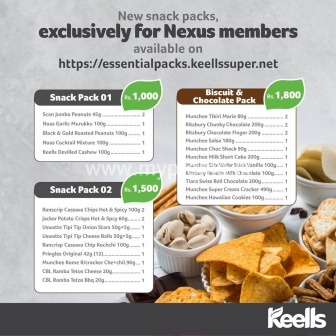If this image were part of a story, what might the story be? Once upon a time in the bustling city of Flavourville, there was an old, charming supermarket named Keells that was known for its rare and exquisite snack packs, available only to its cherished Nexus members. One day, an ambitious young chef named Alex stumbled upon a cryptic message on the store's website promoting these exclusive packs. Intrigued, Alex decided to embark on a flavorful journey to uncover the secrets behind these divine snacks.

Alex became a Nexus member and began exploring each snack pack, discovering unique ingredients and recipes that had been long forgotten by time. Each treat unlocked a new culinary inspiration, helping Alex create dishes that wowed critics and food lovers alike. The supermarket became a hub of culinary excellence, with people traveling from far and wide to taste the creations inspired by the Keells snack packs. And thus, Keells not only revived the lost art of gourmet snacking but also sparked a culinary renaissance in Flavourville, all thanks to the magic and mystery of their one-of-a-kind snack packs. That sounds like a great story! How about a short scenario set in modern times? In today's fast-paced world, Nexus loyalty program members eagerly await the announcement of new snack packs from Keells. Maria, a busy executive, looks forward to these releases as they provide not just a quick snack but a moment of joy in her hectic day. With a variety of options in one convenient pack, Maria can choose from healthy nuts, crunchy chips, and indulgent chocolates without needing to leave her office. These snack packs have become her small daily luxury, helping her power through meetings and deadlines with just a bit more cheer. Describe a scenario where a family might use these snack packs. Imagine a fun-filled Friday evening at the Smith household. The family gathers in the living room for their weekly game night, everyone excitedly anticipating the snacks as much as the games. The parents, John and Sarah, have brought out a selection of the new Keells snack packs they've recently purchased. The kids, Emily and Jack, joyfully dive into the packs, grabbing their favorite treats—Emily loves the chocolate wafers, while Jack goes for the BBQ chips. The laughter and competitive banter are punctuated by the crunch of snacks and the occasional 'yum' as they savor the delicious variety. These snack packs make the family game night even more memorable, providing a delightful mix of flavors for everyone to enjoy. 